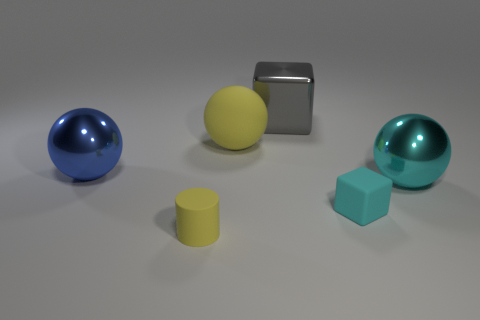There is a sphere that is the same color as the tiny cylinder; what material is it?
Offer a very short reply. Rubber. There is another shiny thing that is the same shape as the large blue object; what size is it?
Your answer should be very brief. Large. What number of things are either large spheres on the right side of the yellow matte cylinder or tiny yellow matte cylinders that are left of the matte ball?
Your response must be concise. 3. Is the size of the cyan ball the same as the metallic cube?
Your answer should be very brief. Yes. Is the number of large things greater than the number of things?
Keep it short and to the point. No. What number of other things are there of the same color as the large block?
Offer a terse response. 0. What number of things are either large rubber spheres or yellow rubber things?
Your answer should be very brief. 2. There is a cyan object to the right of the tiny cyan matte object; is its shape the same as the gray shiny thing?
Give a very brief answer. No. There is a cube in front of the shiny thing that is behind the large matte sphere; what color is it?
Your answer should be very brief. Cyan. Is the number of big rubber spheres less than the number of purple shiny objects?
Give a very brief answer. No. 